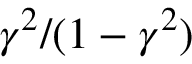<formula> <loc_0><loc_0><loc_500><loc_500>\gamma ^ { 2 } / ( 1 - \gamma ^ { 2 } )</formula> 